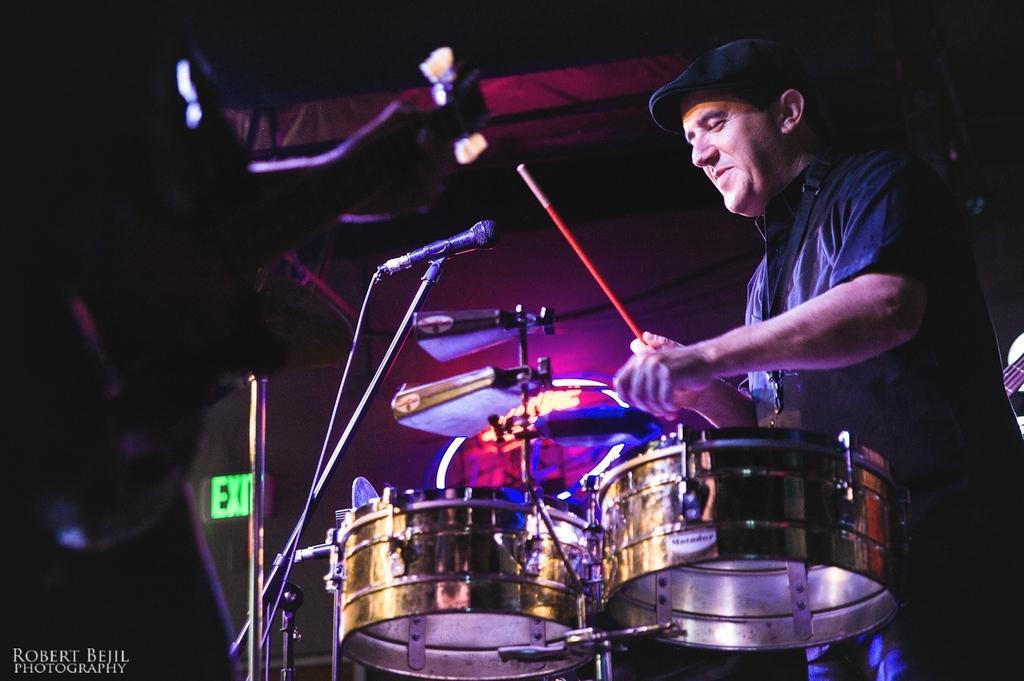In one or two sentences, can you explain what this image depicts? In this picture we can observe a person in front of the drums, holding sticks in his hands. He is wearing black color cap on his head. There is a mic. On the left side there is a person standing. We can observe white color watermark. 